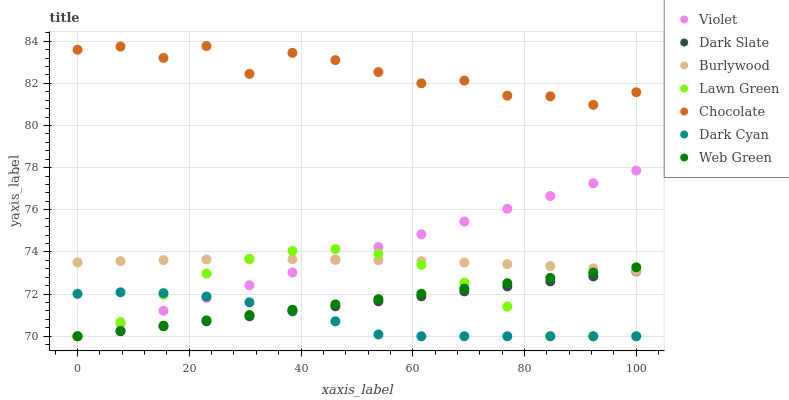Does Dark Cyan have the minimum area under the curve?
Answer yes or no. Yes. Does Chocolate have the maximum area under the curve?
Answer yes or no. Yes. Does Burlywood have the minimum area under the curve?
Answer yes or no. No. Does Burlywood have the maximum area under the curve?
Answer yes or no. No. Is Web Green the smoothest?
Answer yes or no. Yes. Is Chocolate the roughest?
Answer yes or no. Yes. Is Burlywood the smoothest?
Answer yes or no. No. Is Burlywood the roughest?
Answer yes or no. No. Does Lawn Green have the lowest value?
Answer yes or no. Yes. Does Burlywood have the lowest value?
Answer yes or no. No. Does Chocolate have the highest value?
Answer yes or no. Yes. Does Burlywood have the highest value?
Answer yes or no. No. Is Dark Cyan less than Chocolate?
Answer yes or no. Yes. Is Chocolate greater than Lawn Green?
Answer yes or no. Yes. Does Web Green intersect Lawn Green?
Answer yes or no. Yes. Is Web Green less than Lawn Green?
Answer yes or no. No. Is Web Green greater than Lawn Green?
Answer yes or no. No. Does Dark Cyan intersect Chocolate?
Answer yes or no. No. 